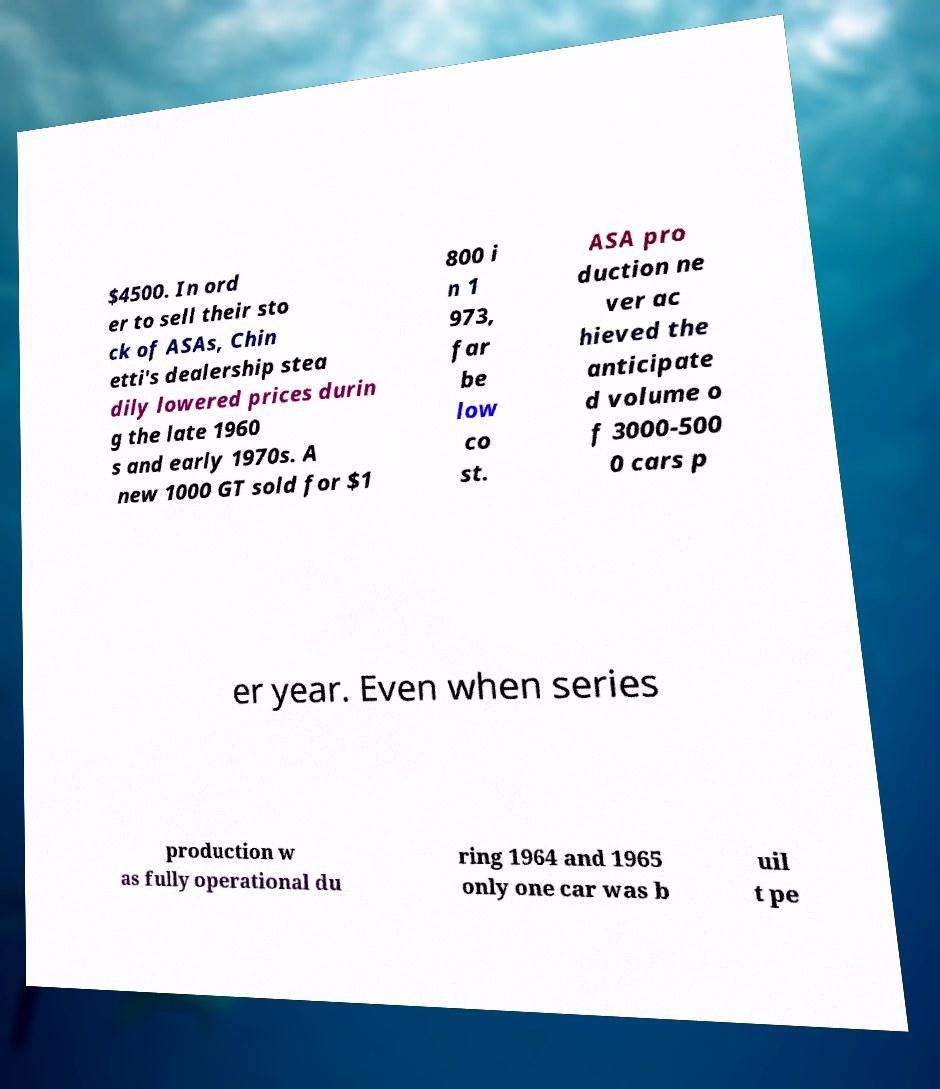I need the written content from this picture converted into text. Can you do that? $4500. In ord er to sell their sto ck of ASAs, Chin etti's dealership stea dily lowered prices durin g the late 1960 s and early 1970s. A new 1000 GT sold for $1 800 i n 1 973, far be low co st. ASA pro duction ne ver ac hieved the anticipate d volume o f 3000-500 0 cars p er year. Even when series production w as fully operational du ring 1964 and 1965 only one car was b uil t pe 